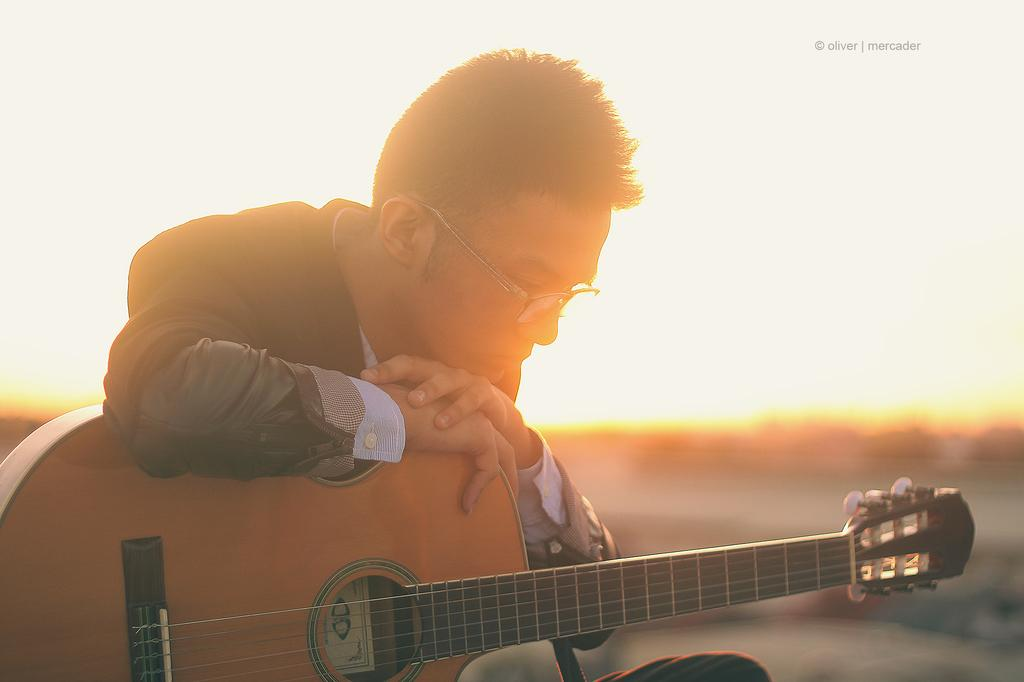What can be seen in the background of the image? There is a sky visible in the image. What is the main subject of the image? There is a man in the image. What is the man holding in the image? The man is holding a guitar. What color crayon is the man using to draw on his stomach in the image? There is no crayon or drawing on the man's stomach present in the image. 